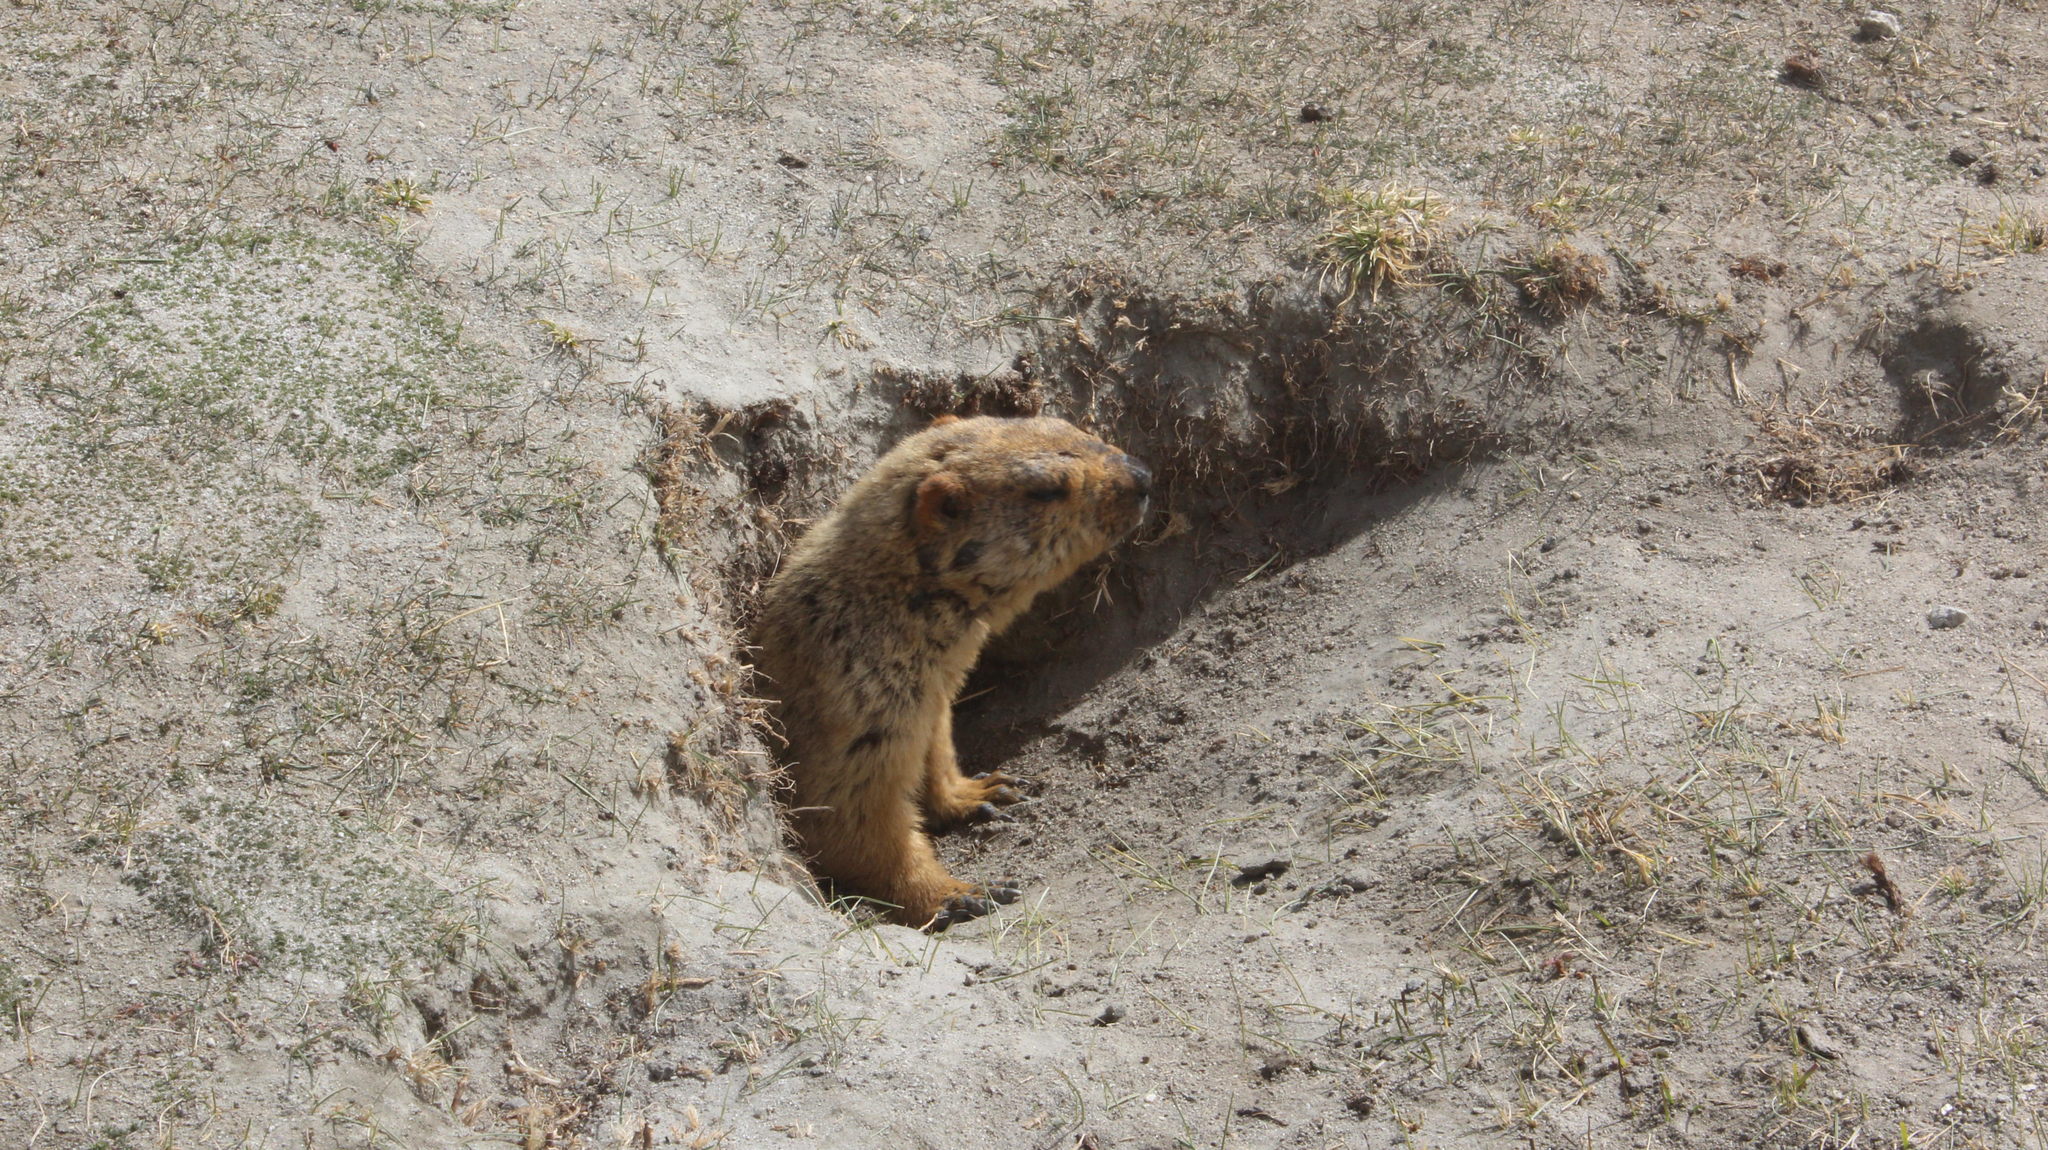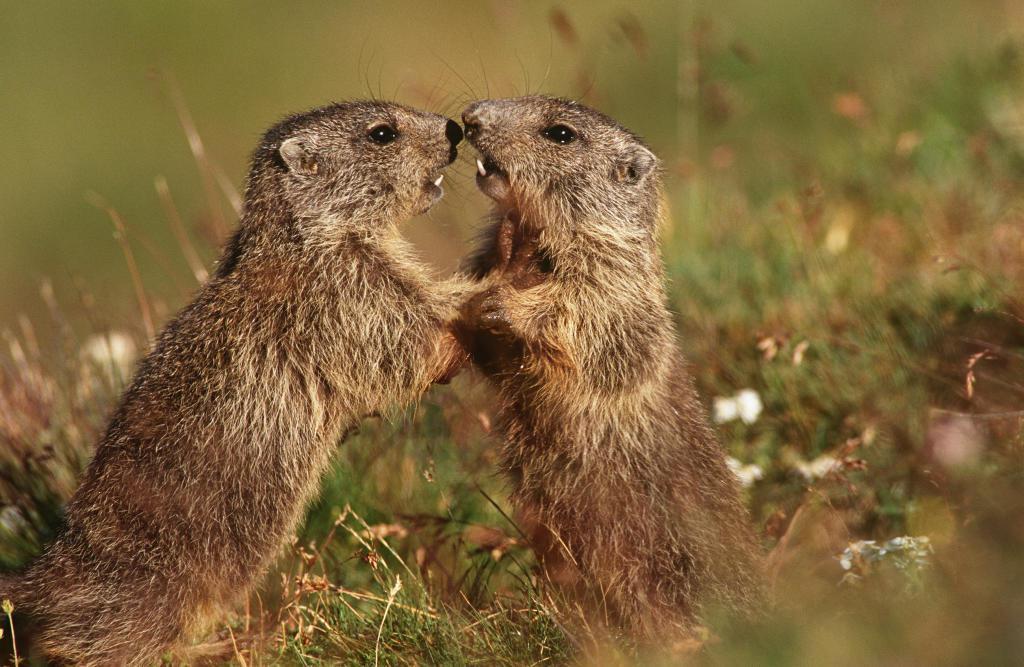The first image is the image on the left, the second image is the image on the right. Examine the images to the left and right. Is the description "We've got three groundhogs here." accurate? Answer yes or no. Yes. The first image is the image on the left, the second image is the image on the right. For the images shown, is this caption "The right image contains at least two rodents." true? Answer yes or no. Yes. 